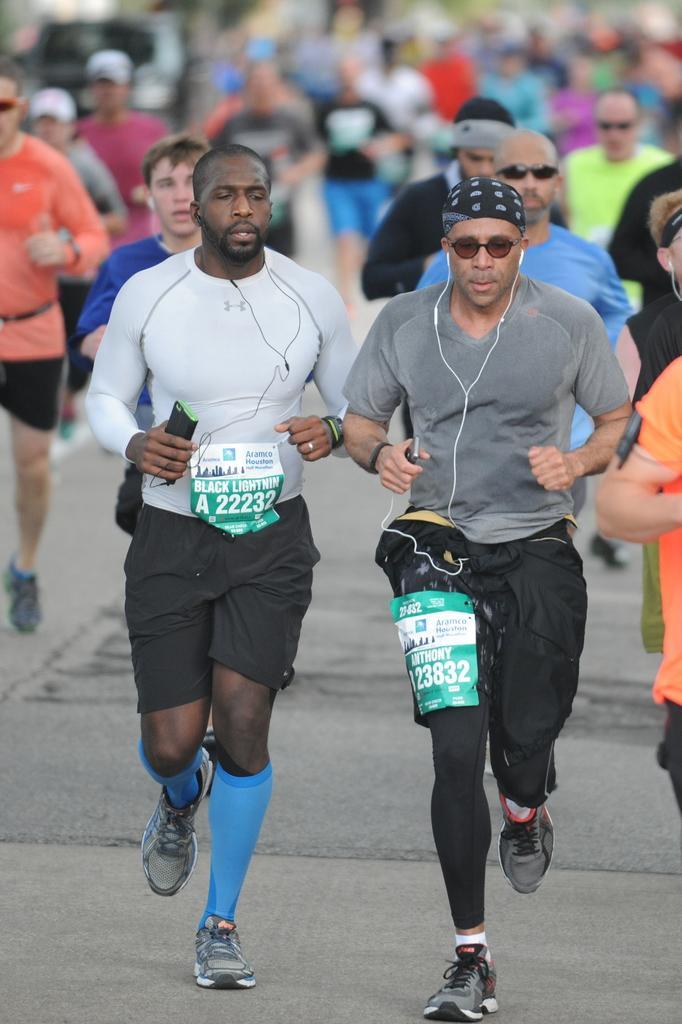In one or two sentences, can you explain what this image depicts? This is a picture of group of people running on the road among them three people are holding mobile phone and wearing earphones. 